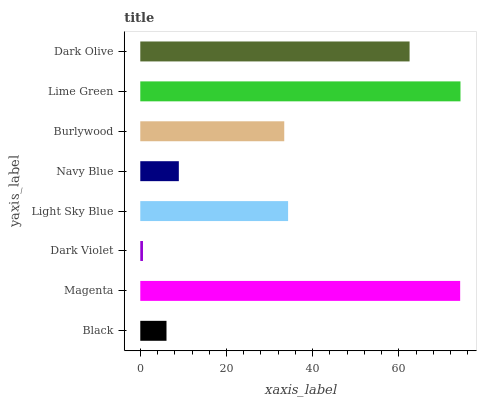Is Dark Violet the minimum?
Answer yes or no. Yes. Is Lime Green the maximum?
Answer yes or no. Yes. Is Magenta the minimum?
Answer yes or no. No. Is Magenta the maximum?
Answer yes or no. No. Is Magenta greater than Black?
Answer yes or no. Yes. Is Black less than Magenta?
Answer yes or no. Yes. Is Black greater than Magenta?
Answer yes or no. No. Is Magenta less than Black?
Answer yes or no. No. Is Light Sky Blue the high median?
Answer yes or no. Yes. Is Burlywood the low median?
Answer yes or no. Yes. Is Dark Olive the high median?
Answer yes or no. No. Is Dark Olive the low median?
Answer yes or no. No. 